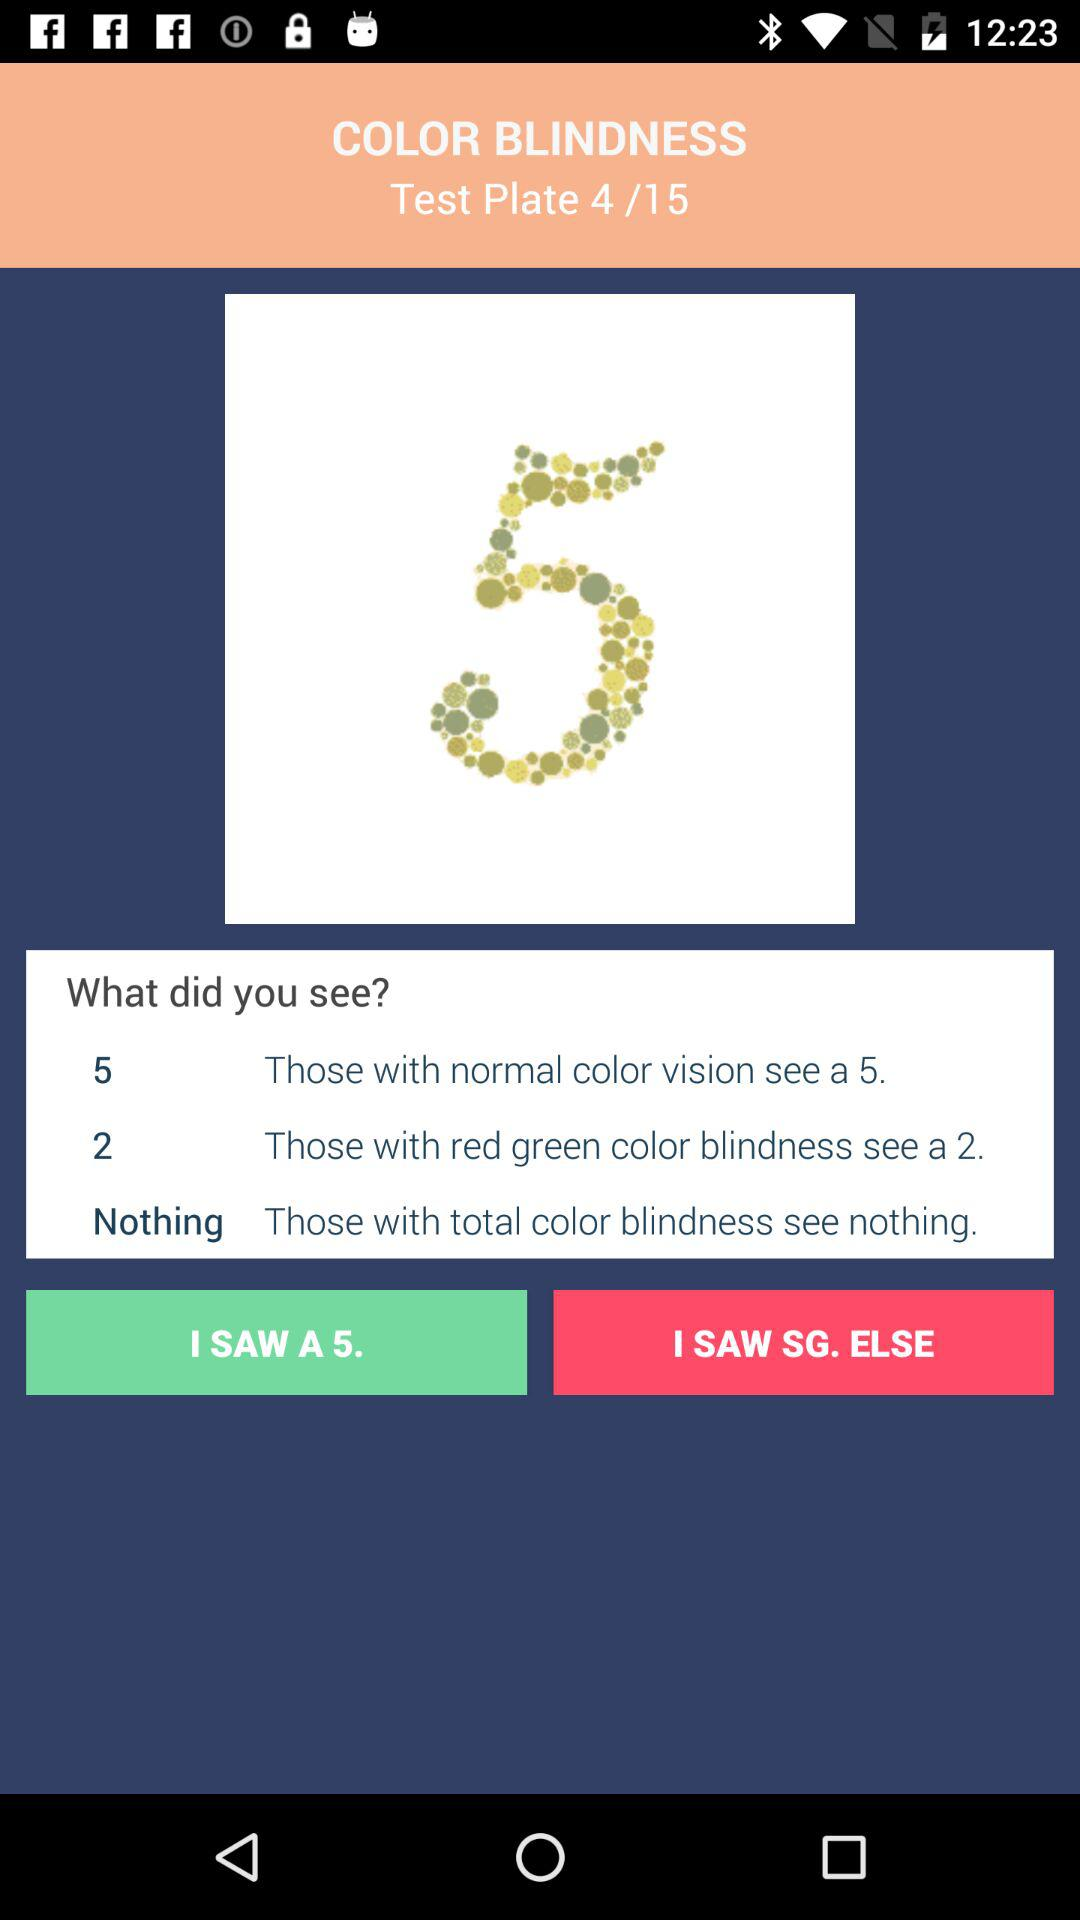Which is the number of the current test plate shown on the screen? The number of the current test plate is 4. 